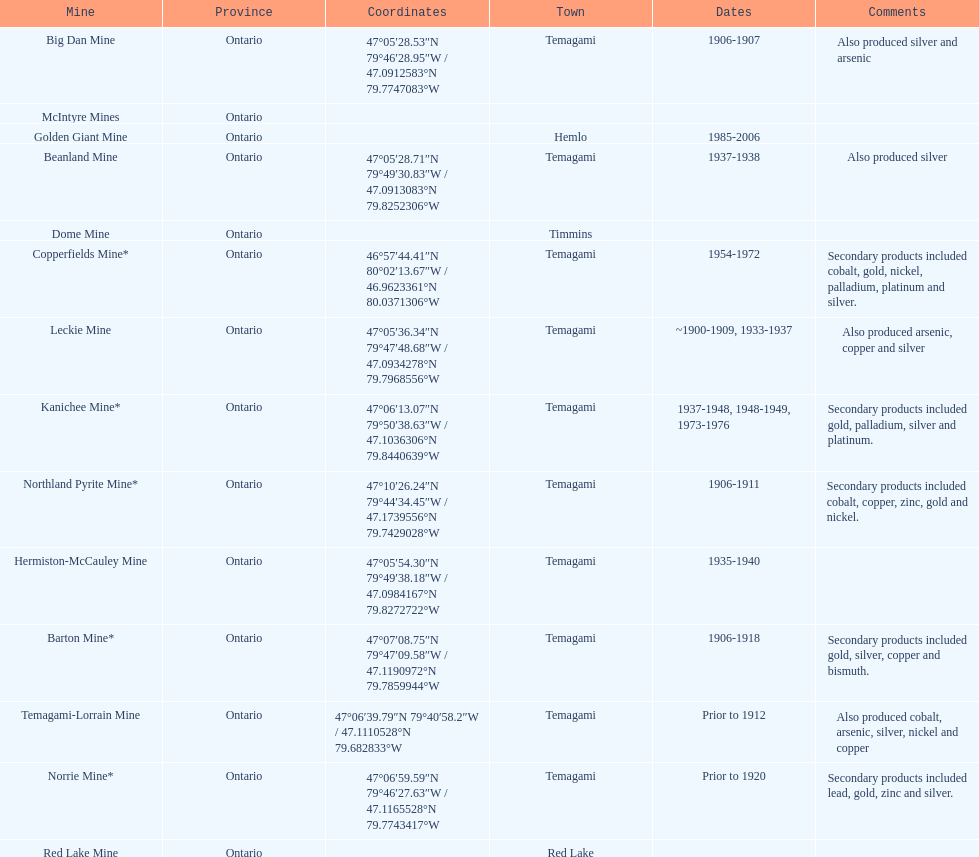How many mines were in temagami? 10. 